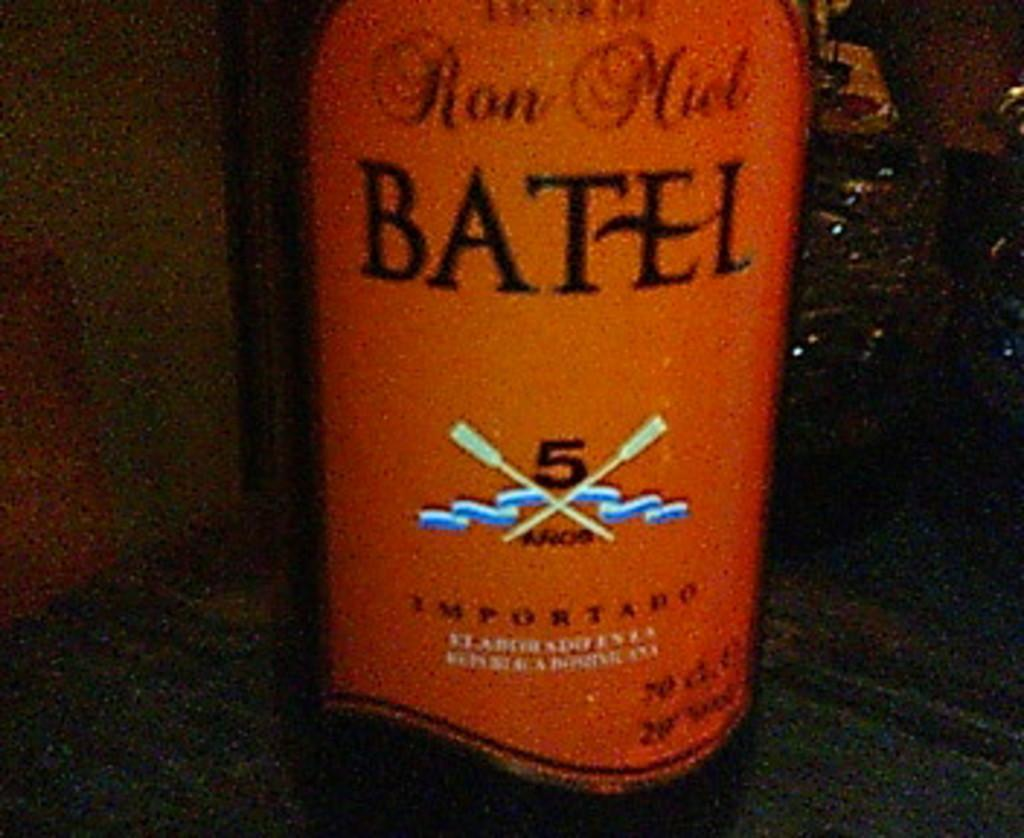<image>
Present a compact description of the photo's key features. A bottle of Batel has the number 5 on the orange label. 